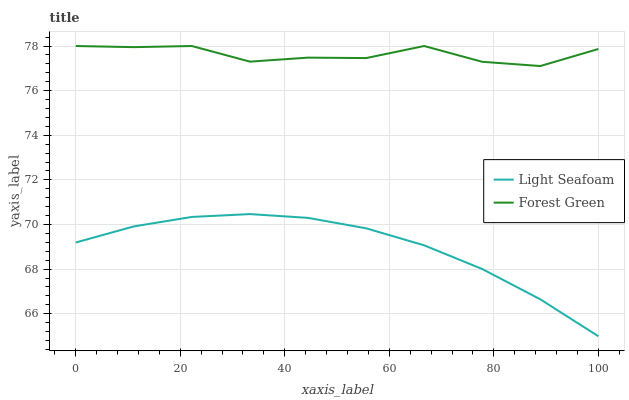Does Light Seafoam have the maximum area under the curve?
Answer yes or no. No. Is Light Seafoam the roughest?
Answer yes or no. No. Does Light Seafoam have the highest value?
Answer yes or no. No. Is Light Seafoam less than Forest Green?
Answer yes or no. Yes. Is Forest Green greater than Light Seafoam?
Answer yes or no. Yes. Does Light Seafoam intersect Forest Green?
Answer yes or no. No. 